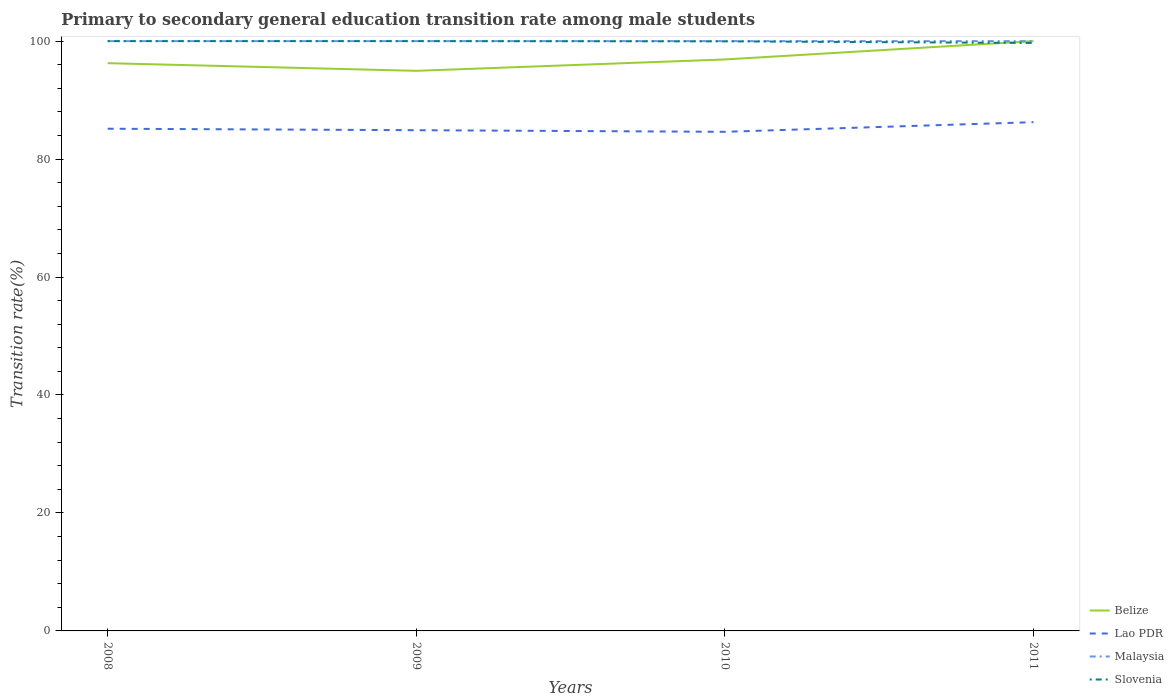Is the number of lines equal to the number of legend labels?
Offer a terse response. Yes. Across all years, what is the maximum transition rate in Lao PDR?
Provide a short and direct response. 84.62. In which year was the transition rate in Belize maximum?
Your response must be concise. 2009. What is the total transition rate in Slovenia in the graph?
Keep it short and to the point. 0.31. What is the difference between the highest and the second highest transition rate in Malaysia?
Make the answer very short. 0. What is the difference between the highest and the lowest transition rate in Malaysia?
Offer a terse response. 0. How many lines are there?
Ensure brevity in your answer.  4. What is the difference between two consecutive major ticks on the Y-axis?
Provide a short and direct response. 20. Are the values on the major ticks of Y-axis written in scientific E-notation?
Provide a succinct answer. No. Does the graph contain grids?
Your answer should be compact. No. Where does the legend appear in the graph?
Provide a succinct answer. Bottom right. How many legend labels are there?
Offer a terse response. 4. How are the legend labels stacked?
Provide a short and direct response. Vertical. What is the title of the graph?
Offer a very short reply. Primary to secondary general education transition rate among male students. Does "Lithuania" appear as one of the legend labels in the graph?
Your response must be concise. No. What is the label or title of the X-axis?
Keep it short and to the point. Years. What is the label or title of the Y-axis?
Make the answer very short. Transition rate(%). What is the Transition rate(%) of Belize in 2008?
Ensure brevity in your answer.  96.26. What is the Transition rate(%) in Lao PDR in 2008?
Make the answer very short. 85.15. What is the Transition rate(%) in Malaysia in 2008?
Provide a short and direct response. 100. What is the Transition rate(%) of Belize in 2009?
Give a very brief answer. 94.96. What is the Transition rate(%) of Lao PDR in 2009?
Offer a very short reply. 84.9. What is the Transition rate(%) of Belize in 2010?
Your answer should be very brief. 96.89. What is the Transition rate(%) of Lao PDR in 2010?
Offer a very short reply. 84.62. What is the Transition rate(%) of Slovenia in 2010?
Offer a terse response. 99.96. What is the Transition rate(%) in Lao PDR in 2011?
Offer a very short reply. 86.26. What is the Transition rate(%) of Malaysia in 2011?
Ensure brevity in your answer.  100. What is the Transition rate(%) in Slovenia in 2011?
Your answer should be compact. 99.69. Across all years, what is the maximum Transition rate(%) in Belize?
Provide a succinct answer. 100. Across all years, what is the maximum Transition rate(%) in Lao PDR?
Give a very brief answer. 86.26. Across all years, what is the maximum Transition rate(%) in Malaysia?
Keep it short and to the point. 100. Across all years, what is the maximum Transition rate(%) in Slovenia?
Offer a very short reply. 100. Across all years, what is the minimum Transition rate(%) in Belize?
Offer a very short reply. 94.96. Across all years, what is the minimum Transition rate(%) in Lao PDR?
Provide a short and direct response. 84.62. Across all years, what is the minimum Transition rate(%) in Malaysia?
Offer a very short reply. 100. Across all years, what is the minimum Transition rate(%) of Slovenia?
Keep it short and to the point. 99.69. What is the total Transition rate(%) in Belize in the graph?
Your answer should be compact. 388.11. What is the total Transition rate(%) in Lao PDR in the graph?
Offer a terse response. 340.92. What is the total Transition rate(%) of Slovenia in the graph?
Your response must be concise. 399.65. What is the difference between the Transition rate(%) in Belize in 2008 and that in 2009?
Provide a short and direct response. 1.3. What is the difference between the Transition rate(%) in Lao PDR in 2008 and that in 2009?
Give a very brief answer. 0.25. What is the difference between the Transition rate(%) of Belize in 2008 and that in 2010?
Give a very brief answer. -0.63. What is the difference between the Transition rate(%) of Lao PDR in 2008 and that in 2010?
Your answer should be very brief. 0.52. What is the difference between the Transition rate(%) of Malaysia in 2008 and that in 2010?
Your answer should be very brief. 0. What is the difference between the Transition rate(%) of Slovenia in 2008 and that in 2010?
Your answer should be compact. 0.04. What is the difference between the Transition rate(%) in Belize in 2008 and that in 2011?
Provide a succinct answer. -3.74. What is the difference between the Transition rate(%) in Lao PDR in 2008 and that in 2011?
Ensure brevity in your answer.  -1.11. What is the difference between the Transition rate(%) in Malaysia in 2008 and that in 2011?
Ensure brevity in your answer.  0. What is the difference between the Transition rate(%) in Slovenia in 2008 and that in 2011?
Make the answer very short. 0.31. What is the difference between the Transition rate(%) in Belize in 2009 and that in 2010?
Make the answer very short. -1.93. What is the difference between the Transition rate(%) of Lao PDR in 2009 and that in 2010?
Your answer should be very brief. 0.27. What is the difference between the Transition rate(%) in Slovenia in 2009 and that in 2010?
Ensure brevity in your answer.  0.04. What is the difference between the Transition rate(%) of Belize in 2009 and that in 2011?
Ensure brevity in your answer.  -5.04. What is the difference between the Transition rate(%) in Lao PDR in 2009 and that in 2011?
Your answer should be very brief. -1.36. What is the difference between the Transition rate(%) in Slovenia in 2009 and that in 2011?
Give a very brief answer. 0.31. What is the difference between the Transition rate(%) of Belize in 2010 and that in 2011?
Ensure brevity in your answer.  -3.11. What is the difference between the Transition rate(%) of Lao PDR in 2010 and that in 2011?
Your answer should be very brief. -1.64. What is the difference between the Transition rate(%) of Slovenia in 2010 and that in 2011?
Offer a very short reply. 0.28. What is the difference between the Transition rate(%) in Belize in 2008 and the Transition rate(%) in Lao PDR in 2009?
Provide a short and direct response. 11.37. What is the difference between the Transition rate(%) in Belize in 2008 and the Transition rate(%) in Malaysia in 2009?
Provide a succinct answer. -3.74. What is the difference between the Transition rate(%) in Belize in 2008 and the Transition rate(%) in Slovenia in 2009?
Your answer should be very brief. -3.74. What is the difference between the Transition rate(%) in Lao PDR in 2008 and the Transition rate(%) in Malaysia in 2009?
Provide a short and direct response. -14.85. What is the difference between the Transition rate(%) of Lao PDR in 2008 and the Transition rate(%) of Slovenia in 2009?
Keep it short and to the point. -14.85. What is the difference between the Transition rate(%) in Malaysia in 2008 and the Transition rate(%) in Slovenia in 2009?
Keep it short and to the point. 0. What is the difference between the Transition rate(%) of Belize in 2008 and the Transition rate(%) of Lao PDR in 2010?
Your response must be concise. 11.64. What is the difference between the Transition rate(%) in Belize in 2008 and the Transition rate(%) in Malaysia in 2010?
Provide a succinct answer. -3.74. What is the difference between the Transition rate(%) of Belize in 2008 and the Transition rate(%) of Slovenia in 2010?
Your answer should be very brief. -3.7. What is the difference between the Transition rate(%) in Lao PDR in 2008 and the Transition rate(%) in Malaysia in 2010?
Your response must be concise. -14.85. What is the difference between the Transition rate(%) of Lao PDR in 2008 and the Transition rate(%) of Slovenia in 2010?
Your response must be concise. -14.82. What is the difference between the Transition rate(%) in Malaysia in 2008 and the Transition rate(%) in Slovenia in 2010?
Provide a succinct answer. 0.04. What is the difference between the Transition rate(%) of Belize in 2008 and the Transition rate(%) of Lao PDR in 2011?
Your answer should be compact. 10. What is the difference between the Transition rate(%) of Belize in 2008 and the Transition rate(%) of Malaysia in 2011?
Your answer should be compact. -3.74. What is the difference between the Transition rate(%) in Belize in 2008 and the Transition rate(%) in Slovenia in 2011?
Make the answer very short. -3.43. What is the difference between the Transition rate(%) in Lao PDR in 2008 and the Transition rate(%) in Malaysia in 2011?
Your answer should be compact. -14.85. What is the difference between the Transition rate(%) in Lao PDR in 2008 and the Transition rate(%) in Slovenia in 2011?
Your answer should be compact. -14.54. What is the difference between the Transition rate(%) of Malaysia in 2008 and the Transition rate(%) of Slovenia in 2011?
Make the answer very short. 0.31. What is the difference between the Transition rate(%) of Belize in 2009 and the Transition rate(%) of Lao PDR in 2010?
Offer a terse response. 10.34. What is the difference between the Transition rate(%) in Belize in 2009 and the Transition rate(%) in Malaysia in 2010?
Keep it short and to the point. -5.04. What is the difference between the Transition rate(%) in Belize in 2009 and the Transition rate(%) in Slovenia in 2010?
Provide a short and direct response. -5. What is the difference between the Transition rate(%) in Lao PDR in 2009 and the Transition rate(%) in Malaysia in 2010?
Make the answer very short. -15.1. What is the difference between the Transition rate(%) in Lao PDR in 2009 and the Transition rate(%) in Slovenia in 2010?
Keep it short and to the point. -15.07. What is the difference between the Transition rate(%) of Malaysia in 2009 and the Transition rate(%) of Slovenia in 2010?
Make the answer very short. 0.04. What is the difference between the Transition rate(%) in Belize in 2009 and the Transition rate(%) in Lao PDR in 2011?
Your response must be concise. 8.7. What is the difference between the Transition rate(%) in Belize in 2009 and the Transition rate(%) in Malaysia in 2011?
Your answer should be very brief. -5.04. What is the difference between the Transition rate(%) of Belize in 2009 and the Transition rate(%) of Slovenia in 2011?
Your answer should be compact. -4.73. What is the difference between the Transition rate(%) of Lao PDR in 2009 and the Transition rate(%) of Malaysia in 2011?
Your answer should be compact. -15.1. What is the difference between the Transition rate(%) of Lao PDR in 2009 and the Transition rate(%) of Slovenia in 2011?
Make the answer very short. -14.79. What is the difference between the Transition rate(%) of Malaysia in 2009 and the Transition rate(%) of Slovenia in 2011?
Provide a short and direct response. 0.31. What is the difference between the Transition rate(%) in Belize in 2010 and the Transition rate(%) in Lao PDR in 2011?
Keep it short and to the point. 10.63. What is the difference between the Transition rate(%) in Belize in 2010 and the Transition rate(%) in Malaysia in 2011?
Your response must be concise. -3.11. What is the difference between the Transition rate(%) of Belize in 2010 and the Transition rate(%) of Slovenia in 2011?
Ensure brevity in your answer.  -2.8. What is the difference between the Transition rate(%) of Lao PDR in 2010 and the Transition rate(%) of Malaysia in 2011?
Make the answer very short. -15.38. What is the difference between the Transition rate(%) in Lao PDR in 2010 and the Transition rate(%) in Slovenia in 2011?
Offer a very short reply. -15.07. What is the difference between the Transition rate(%) of Malaysia in 2010 and the Transition rate(%) of Slovenia in 2011?
Your answer should be very brief. 0.31. What is the average Transition rate(%) of Belize per year?
Give a very brief answer. 97.03. What is the average Transition rate(%) in Lao PDR per year?
Give a very brief answer. 85.23. What is the average Transition rate(%) of Malaysia per year?
Offer a very short reply. 100. What is the average Transition rate(%) of Slovenia per year?
Keep it short and to the point. 99.91. In the year 2008, what is the difference between the Transition rate(%) in Belize and Transition rate(%) in Lao PDR?
Keep it short and to the point. 11.12. In the year 2008, what is the difference between the Transition rate(%) of Belize and Transition rate(%) of Malaysia?
Provide a short and direct response. -3.74. In the year 2008, what is the difference between the Transition rate(%) in Belize and Transition rate(%) in Slovenia?
Your answer should be compact. -3.74. In the year 2008, what is the difference between the Transition rate(%) of Lao PDR and Transition rate(%) of Malaysia?
Offer a very short reply. -14.85. In the year 2008, what is the difference between the Transition rate(%) in Lao PDR and Transition rate(%) in Slovenia?
Give a very brief answer. -14.85. In the year 2009, what is the difference between the Transition rate(%) in Belize and Transition rate(%) in Lao PDR?
Make the answer very short. 10.06. In the year 2009, what is the difference between the Transition rate(%) in Belize and Transition rate(%) in Malaysia?
Offer a terse response. -5.04. In the year 2009, what is the difference between the Transition rate(%) of Belize and Transition rate(%) of Slovenia?
Make the answer very short. -5.04. In the year 2009, what is the difference between the Transition rate(%) of Lao PDR and Transition rate(%) of Malaysia?
Provide a short and direct response. -15.1. In the year 2009, what is the difference between the Transition rate(%) in Lao PDR and Transition rate(%) in Slovenia?
Your answer should be compact. -15.1. In the year 2009, what is the difference between the Transition rate(%) of Malaysia and Transition rate(%) of Slovenia?
Offer a terse response. 0. In the year 2010, what is the difference between the Transition rate(%) in Belize and Transition rate(%) in Lao PDR?
Offer a terse response. 12.27. In the year 2010, what is the difference between the Transition rate(%) of Belize and Transition rate(%) of Malaysia?
Provide a short and direct response. -3.11. In the year 2010, what is the difference between the Transition rate(%) of Belize and Transition rate(%) of Slovenia?
Make the answer very short. -3.07. In the year 2010, what is the difference between the Transition rate(%) of Lao PDR and Transition rate(%) of Malaysia?
Make the answer very short. -15.38. In the year 2010, what is the difference between the Transition rate(%) of Lao PDR and Transition rate(%) of Slovenia?
Your answer should be compact. -15.34. In the year 2010, what is the difference between the Transition rate(%) in Malaysia and Transition rate(%) in Slovenia?
Offer a terse response. 0.04. In the year 2011, what is the difference between the Transition rate(%) in Belize and Transition rate(%) in Lao PDR?
Offer a very short reply. 13.74. In the year 2011, what is the difference between the Transition rate(%) in Belize and Transition rate(%) in Slovenia?
Offer a terse response. 0.31. In the year 2011, what is the difference between the Transition rate(%) in Lao PDR and Transition rate(%) in Malaysia?
Ensure brevity in your answer.  -13.74. In the year 2011, what is the difference between the Transition rate(%) of Lao PDR and Transition rate(%) of Slovenia?
Offer a terse response. -13.43. In the year 2011, what is the difference between the Transition rate(%) in Malaysia and Transition rate(%) in Slovenia?
Offer a very short reply. 0.31. What is the ratio of the Transition rate(%) of Belize in 2008 to that in 2009?
Provide a short and direct response. 1.01. What is the ratio of the Transition rate(%) of Belize in 2008 to that in 2010?
Your answer should be compact. 0.99. What is the ratio of the Transition rate(%) of Lao PDR in 2008 to that in 2010?
Give a very brief answer. 1.01. What is the ratio of the Transition rate(%) of Belize in 2008 to that in 2011?
Provide a short and direct response. 0.96. What is the ratio of the Transition rate(%) in Lao PDR in 2008 to that in 2011?
Offer a very short reply. 0.99. What is the ratio of the Transition rate(%) in Malaysia in 2008 to that in 2011?
Keep it short and to the point. 1. What is the ratio of the Transition rate(%) in Belize in 2009 to that in 2010?
Your answer should be compact. 0.98. What is the ratio of the Transition rate(%) of Belize in 2009 to that in 2011?
Provide a succinct answer. 0.95. What is the ratio of the Transition rate(%) of Lao PDR in 2009 to that in 2011?
Provide a short and direct response. 0.98. What is the ratio of the Transition rate(%) of Malaysia in 2009 to that in 2011?
Your answer should be very brief. 1. What is the ratio of the Transition rate(%) in Belize in 2010 to that in 2011?
Provide a short and direct response. 0.97. What is the ratio of the Transition rate(%) of Slovenia in 2010 to that in 2011?
Your response must be concise. 1. What is the difference between the highest and the second highest Transition rate(%) in Belize?
Provide a succinct answer. 3.11. What is the difference between the highest and the second highest Transition rate(%) in Lao PDR?
Offer a terse response. 1.11. What is the difference between the highest and the second highest Transition rate(%) in Slovenia?
Make the answer very short. 0. What is the difference between the highest and the lowest Transition rate(%) in Belize?
Make the answer very short. 5.04. What is the difference between the highest and the lowest Transition rate(%) in Lao PDR?
Your answer should be very brief. 1.64. What is the difference between the highest and the lowest Transition rate(%) in Slovenia?
Your response must be concise. 0.31. 